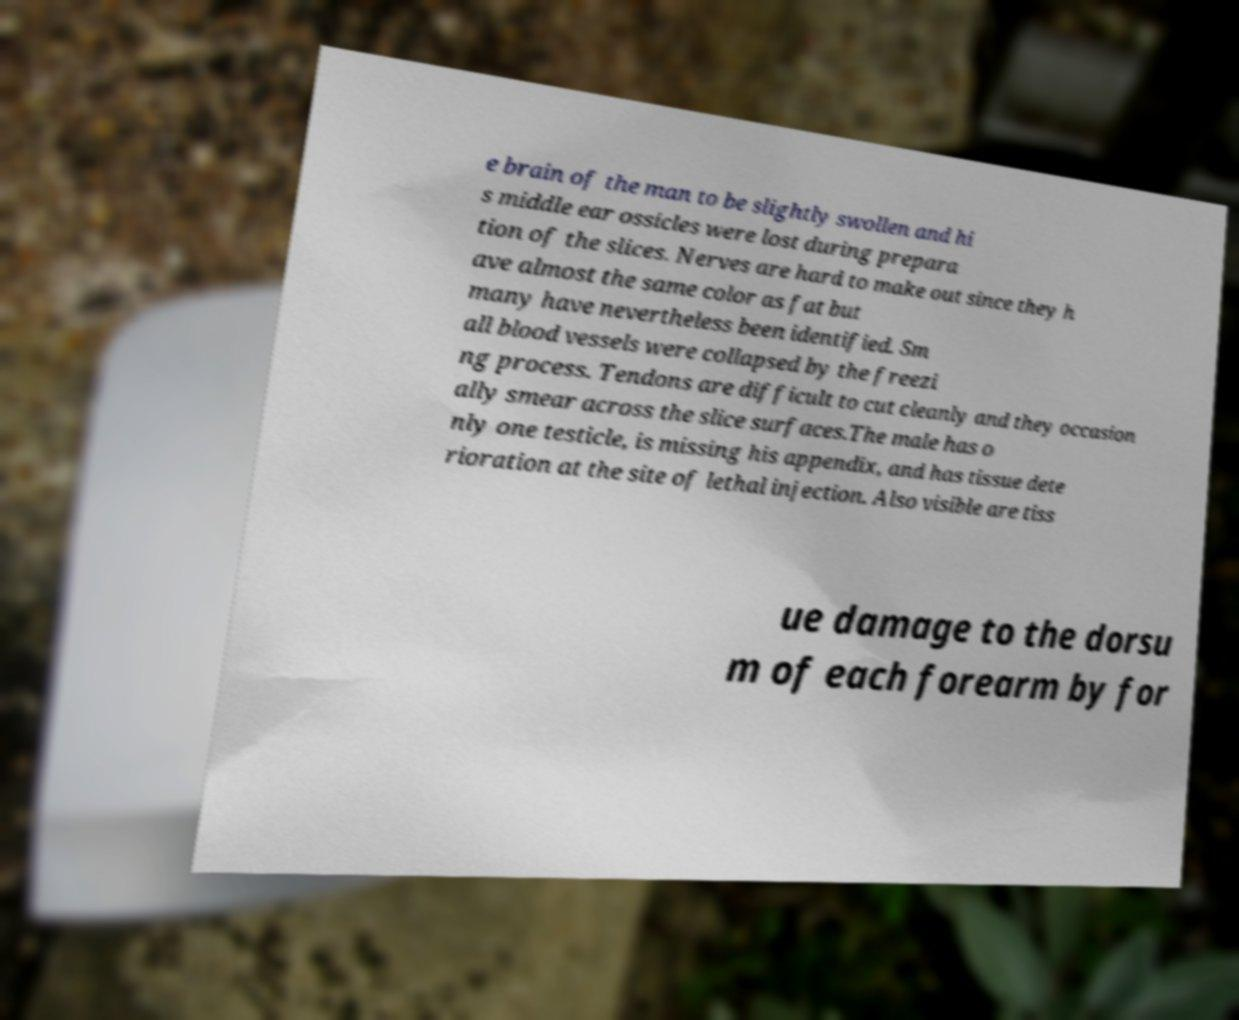What messages or text are displayed in this image? I need them in a readable, typed format. e brain of the man to be slightly swollen and hi s middle ear ossicles were lost during prepara tion of the slices. Nerves are hard to make out since they h ave almost the same color as fat but many have nevertheless been identified. Sm all blood vessels were collapsed by the freezi ng process. Tendons are difficult to cut cleanly and they occasion ally smear across the slice surfaces.The male has o nly one testicle, is missing his appendix, and has tissue dete rioration at the site of lethal injection. Also visible are tiss ue damage to the dorsu m of each forearm by for 